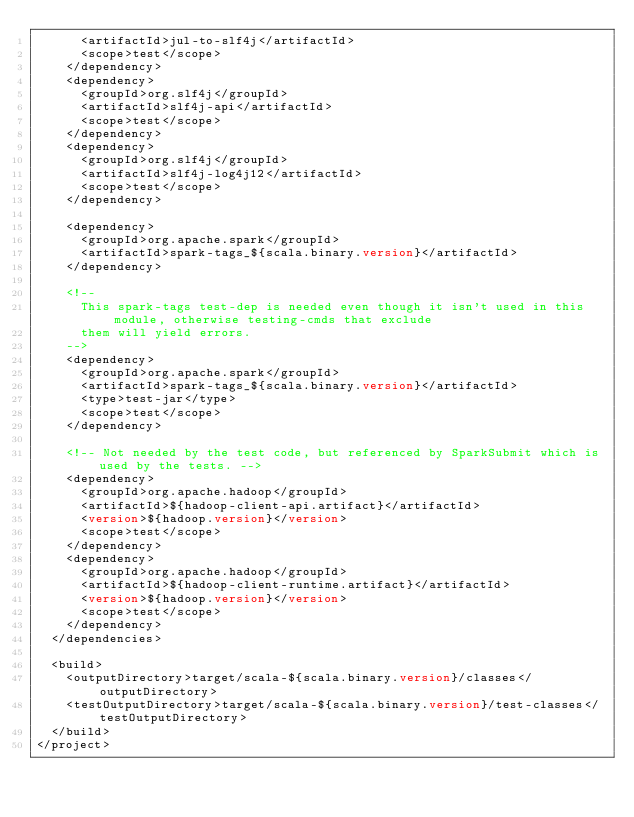Convert code to text. <code><loc_0><loc_0><loc_500><loc_500><_XML_>      <artifactId>jul-to-slf4j</artifactId>
      <scope>test</scope>
    </dependency>
    <dependency>
      <groupId>org.slf4j</groupId>
      <artifactId>slf4j-api</artifactId>
      <scope>test</scope>
    </dependency>
    <dependency>
      <groupId>org.slf4j</groupId>
      <artifactId>slf4j-log4j12</artifactId>
      <scope>test</scope>
    </dependency>

    <dependency>
      <groupId>org.apache.spark</groupId>
      <artifactId>spark-tags_${scala.binary.version}</artifactId>
    </dependency>

    <!--
      This spark-tags test-dep is needed even though it isn't used in this module, otherwise testing-cmds that exclude
      them will yield errors.
    -->
    <dependency>
      <groupId>org.apache.spark</groupId>
      <artifactId>spark-tags_${scala.binary.version}</artifactId>
      <type>test-jar</type>
      <scope>test</scope>
    </dependency>

    <!-- Not needed by the test code, but referenced by SparkSubmit which is used by the tests. -->
    <dependency>
      <groupId>org.apache.hadoop</groupId>
      <artifactId>${hadoop-client-api.artifact}</artifactId>
      <version>${hadoop.version}</version>
      <scope>test</scope>
    </dependency>
    <dependency>
      <groupId>org.apache.hadoop</groupId>
      <artifactId>${hadoop-client-runtime.artifact}</artifactId>
      <version>${hadoop.version}</version>
      <scope>test</scope>
    </dependency>
  </dependencies>

  <build>
    <outputDirectory>target/scala-${scala.binary.version}/classes</outputDirectory>
    <testOutputDirectory>target/scala-${scala.binary.version}/test-classes</testOutputDirectory>
  </build>
</project>
</code> 